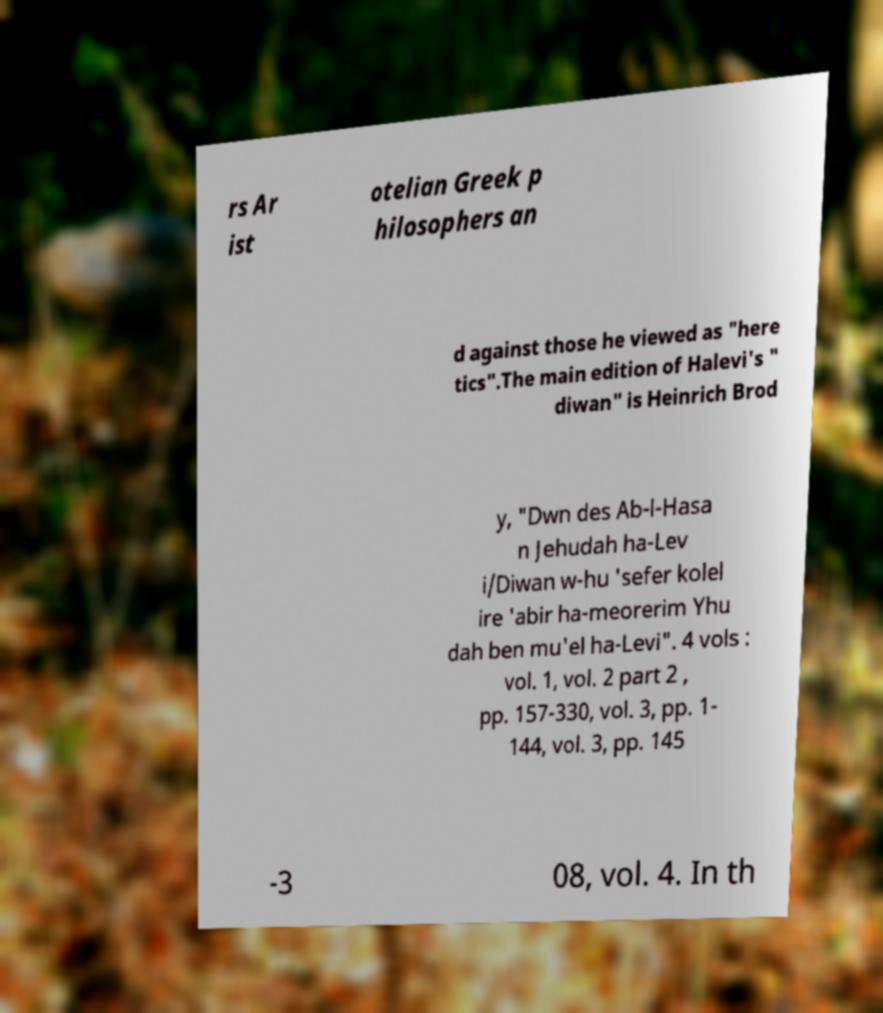Please identify and transcribe the text found in this image. rs Ar ist otelian Greek p hilosophers an d against those he viewed as "here tics".The main edition of Halevi's " diwan" is Heinrich Brod y, "Dwn des Ab-l-Hasa n Jehudah ha-Lev i/Diwan w-hu 'sefer kolel ire 'abir ha-meorerim Yhu dah ben mu'el ha-Levi". 4 vols : vol. 1, vol. 2 part 2 , pp. 157-330, vol. 3, pp. 1- 144, vol. 3, pp. 145 -3 08, vol. 4. In th 